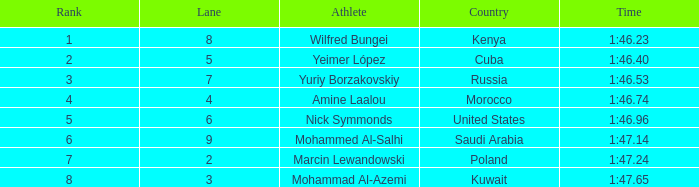What is the placement of the sportsman with a time of 1:4 None. 